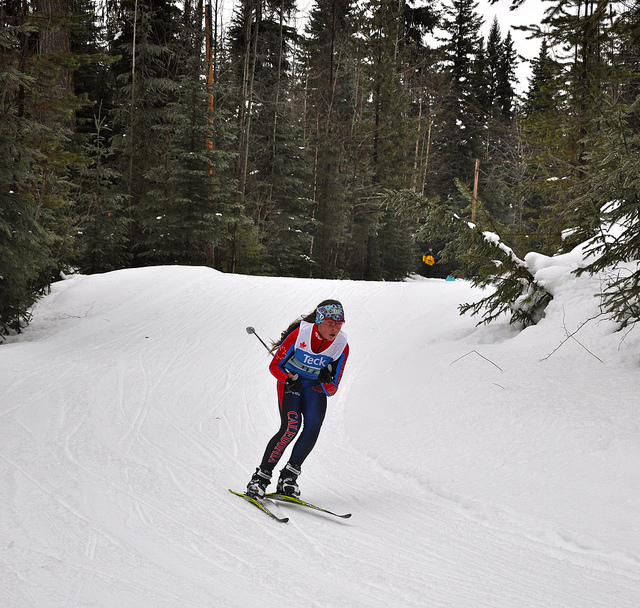Read all the text in this image. Teck 